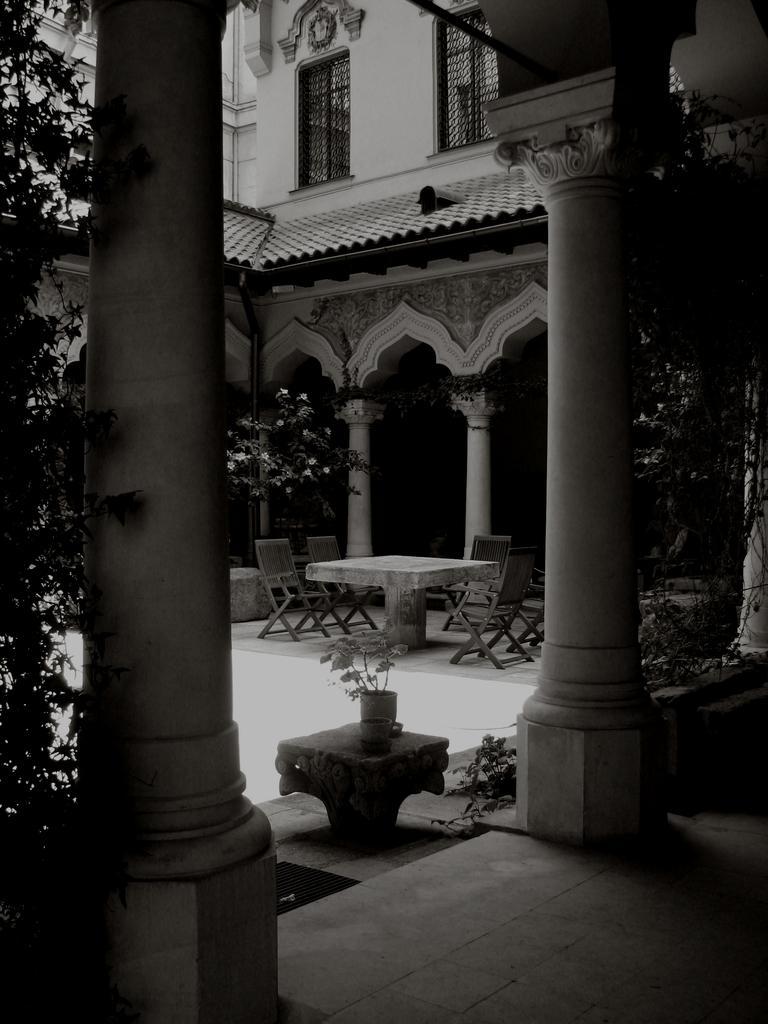Can you describe this image briefly? This is a black and white pic. Here we can see plants,pillars,windows,floor,wall and chairs at the table. 